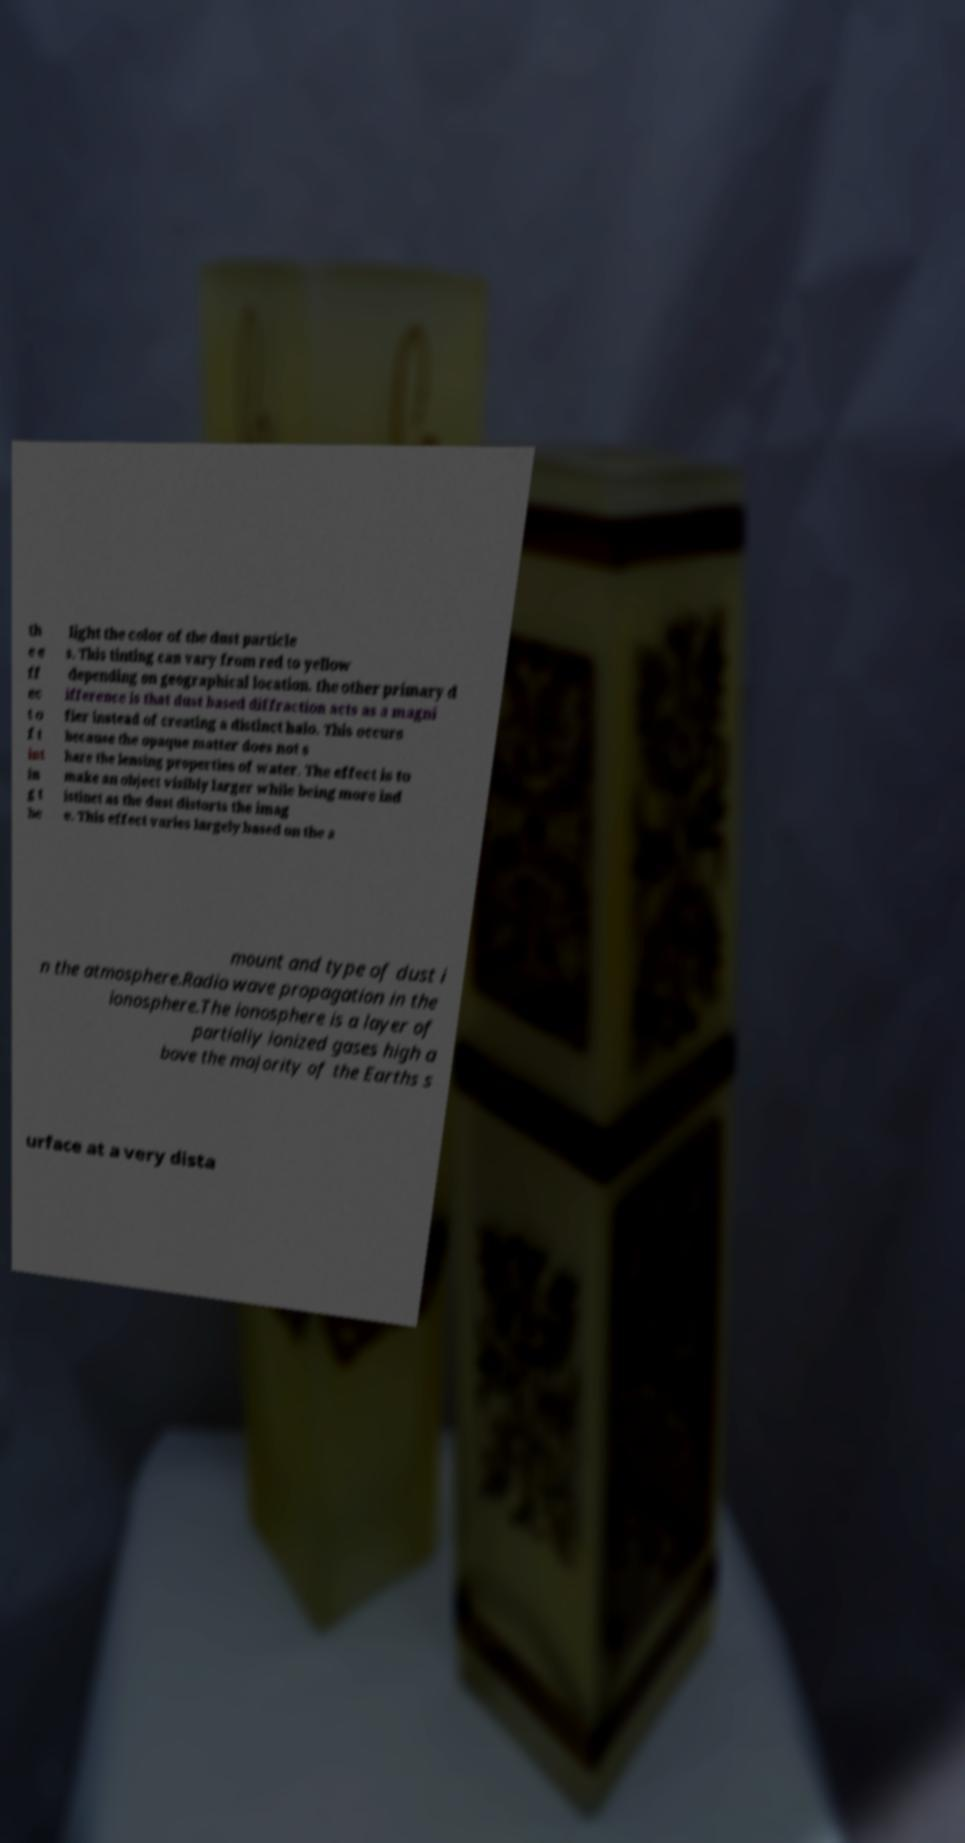There's text embedded in this image that I need extracted. Can you transcribe it verbatim? th e e ff ec t o f t int in g t he light the color of the dust particle s. This tinting can vary from red to yellow depending on geographical location. the other primary d ifference is that dust based diffraction acts as a magni fier instead of creating a distinct halo. This occurs because the opaque matter does not s hare the lensing properties of water. The effect is to make an object visibly larger while being more ind istinct as the dust distorts the imag e. This effect varies largely based on the a mount and type of dust i n the atmosphere.Radio wave propagation in the ionosphere.The ionosphere is a layer of partially ionized gases high a bove the majority of the Earths s urface at a very dista 